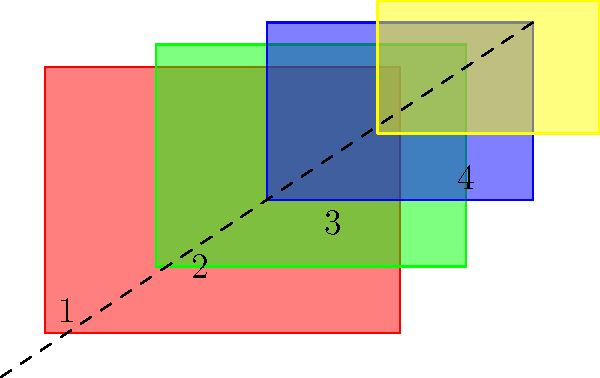To create a visually appealing collage effect with overlapping image layers, which order of arrangement (from bottom to top) would you recommend for the numbered rectangles? To create a visually appealing collage effect with overlapping image layers, we need to consider the following principles:

1. Contrast: Ensure that adjacent layers have good color contrast for visual distinction.
2. Gradual size change: Arrange layers so that their sizes transition smoothly.
3. Diagonal composition: Create a sense of depth and movement by arranging layers along a diagonal.

Analyzing the given rectangles:
1. Red rectangle (1): Largest and covers the most area.
2. Green rectangle (2): Second largest, slightly smaller than red.
3. Blue rectangle (3): Third largest, noticeably smaller than green.
4. Yellow rectangle (4): Smallest rectangle.

The optimal arrangement from bottom to top would be:

1. Start with the red rectangle (1) as the base layer.
2. Place the green rectangle (2) on top, slightly overlapping the red one.
3. Add the blue rectangle (3) next, overlapping both red and green.
4. Finally, place the yellow rectangle (4) on top, creating a diagonal composition.

This arrangement creates a gradual size transition from large to small, maintains good color contrast between adjacent layers, and follows the diagonal composition guideline (as indicated by the dashed line in the diagram).
Answer: 1, 2, 3, 4 